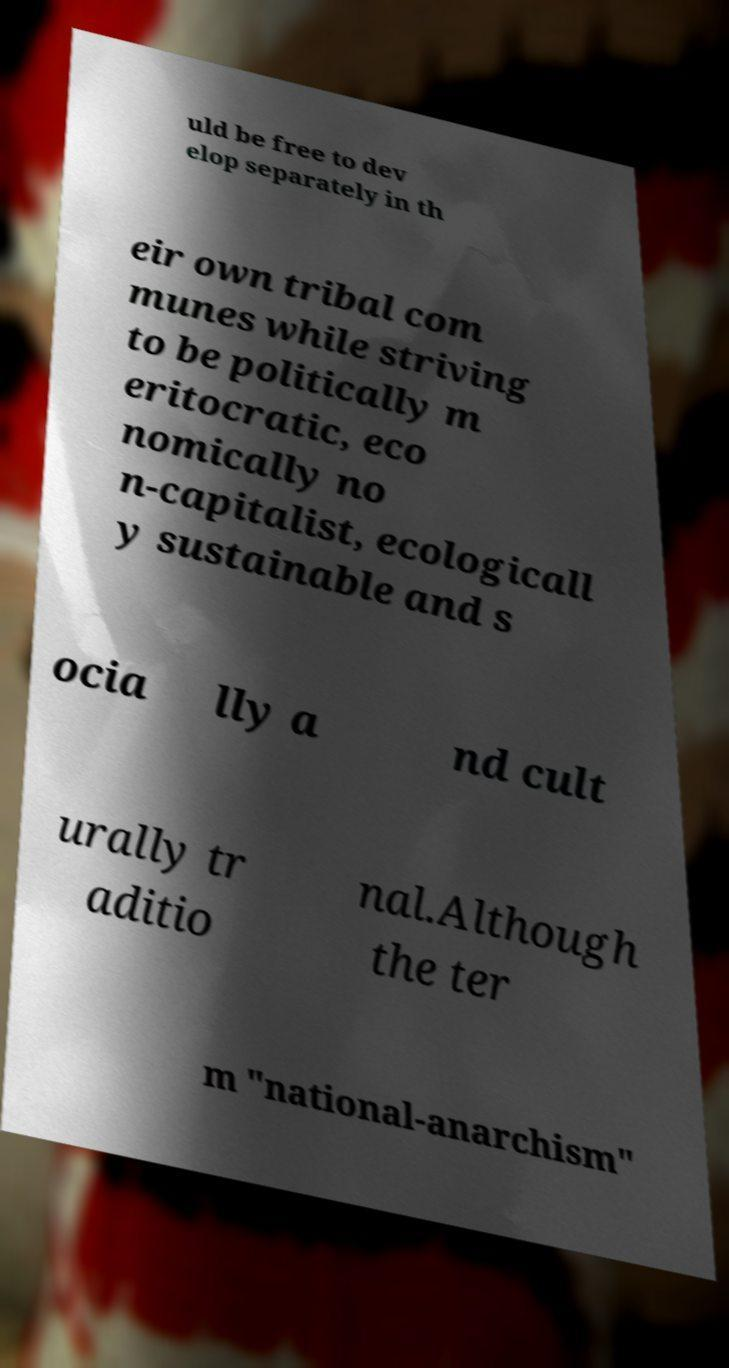There's text embedded in this image that I need extracted. Can you transcribe it verbatim? uld be free to dev elop separately in th eir own tribal com munes while striving to be politically m eritocratic, eco nomically no n-capitalist, ecologicall y sustainable and s ocia lly a nd cult urally tr aditio nal.Although the ter m "national-anarchism" 